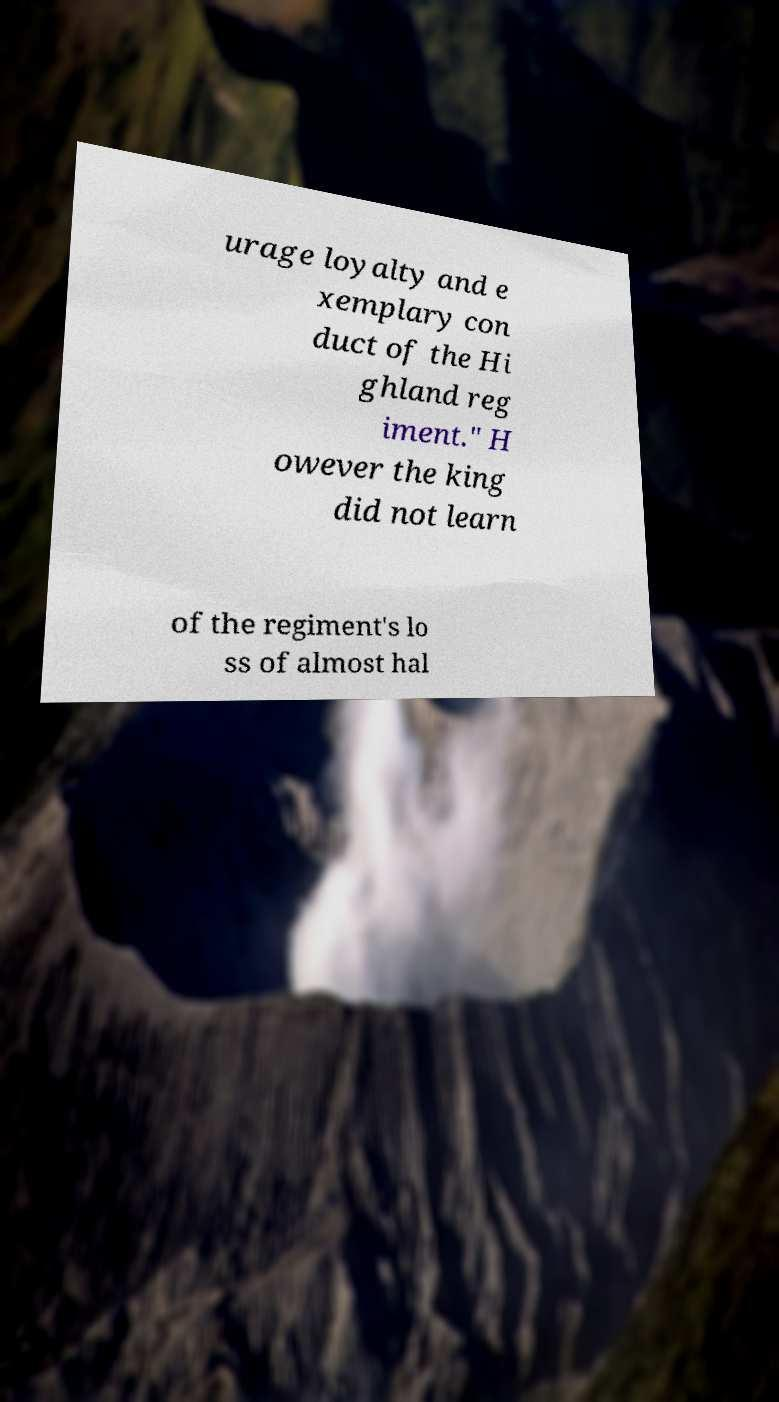Please identify and transcribe the text found in this image. urage loyalty and e xemplary con duct of the Hi ghland reg iment." H owever the king did not learn of the regiment's lo ss of almost hal 